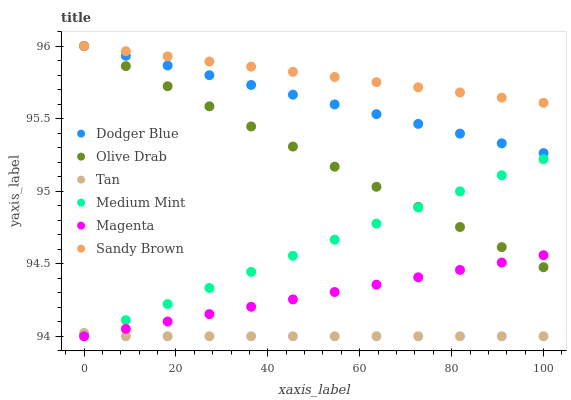Does Tan have the minimum area under the curve?
Answer yes or no. Yes. Does Sandy Brown have the maximum area under the curve?
Answer yes or no. Yes. Does Dodger Blue have the minimum area under the curve?
Answer yes or no. No. Does Dodger Blue have the maximum area under the curve?
Answer yes or no. No. Is Medium Mint the smoothest?
Answer yes or no. Yes. Is Tan the roughest?
Answer yes or no. Yes. Is Dodger Blue the smoothest?
Answer yes or no. No. Is Dodger Blue the roughest?
Answer yes or no. No. Does Medium Mint have the lowest value?
Answer yes or no. Yes. Does Dodger Blue have the lowest value?
Answer yes or no. No. Does Olive Drab have the highest value?
Answer yes or no. Yes. Does Tan have the highest value?
Answer yes or no. No. Is Medium Mint less than Dodger Blue?
Answer yes or no. Yes. Is Sandy Brown greater than Tan?
Answer yes or no. Yes. Does Magenta intersect Tan?
Answer yes or no. Yes. Is Magenta less than Tan?
Answer yes or no. No. Is Magenta greater than Tan?
Answer yes or no. No. Does Medium Mint intersect Dodger Blue?
Answer yes or no. No. 